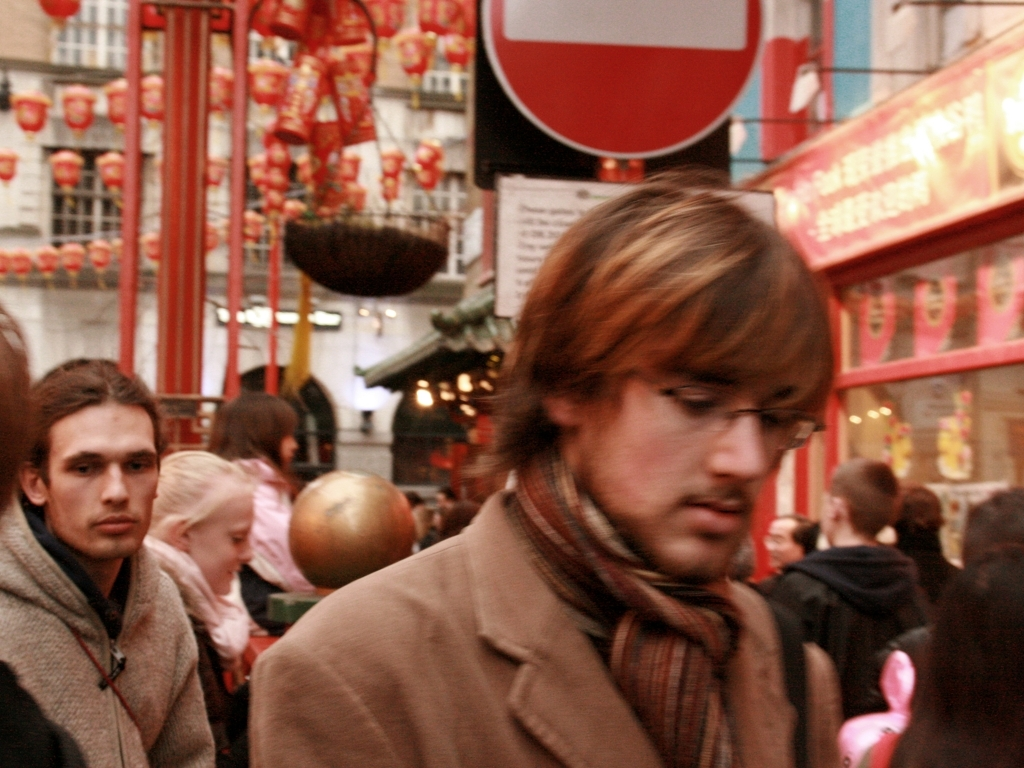Please describe any cultural elements visible in this image. This image features several cultural elements that might suggest a festival or special occasion related to the East Asian community, such as Chinese New Year. Notably, red lanterns and festive decorations adorn the space, symbolizing celebration and good fortune. The area seems to be a cultural hub, likely within a city with a significant East Asian presence, given the focused thematic elements and signage. 